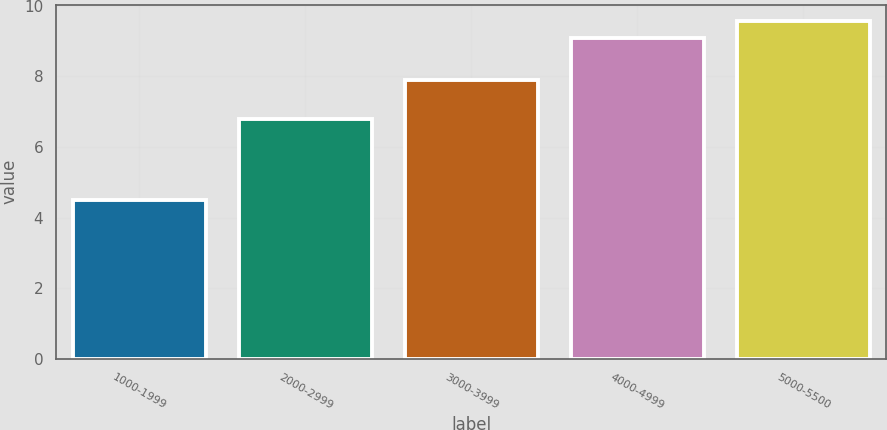Convert chart to OTSL. <chart><loc_0><loc_0><loc_500><loc_500><bar_chart><fcel>1000-1999<fcel>2000-2999<fcel>3000-3999<fcel>4000-4999<fcel>5000-5500<nl><fcel>4.5<fcel>6.8<fcel>7.9<fcel>9.1<fcel>9.56<nl></chart> 